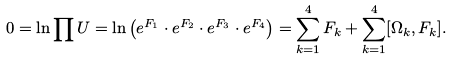Convert formula to latex. <formula><loc_0><loc_0><loc_500><loc_500>0 = \ln \prod U = \ln \left ( e ^ { F _ { 1 } } \cdot e ^ { F _ { 2 } } \cdot e ^ { F _ { 3 } } \cdot e ^ { F _ { 4 } } \right ) = \sum _ { k = 1 } ^ { 4 } F _ { k } + \sum _ { k = 1 } ^ { 4 } [ \Omega _ { k } , F _ { k } ] .</formula> 